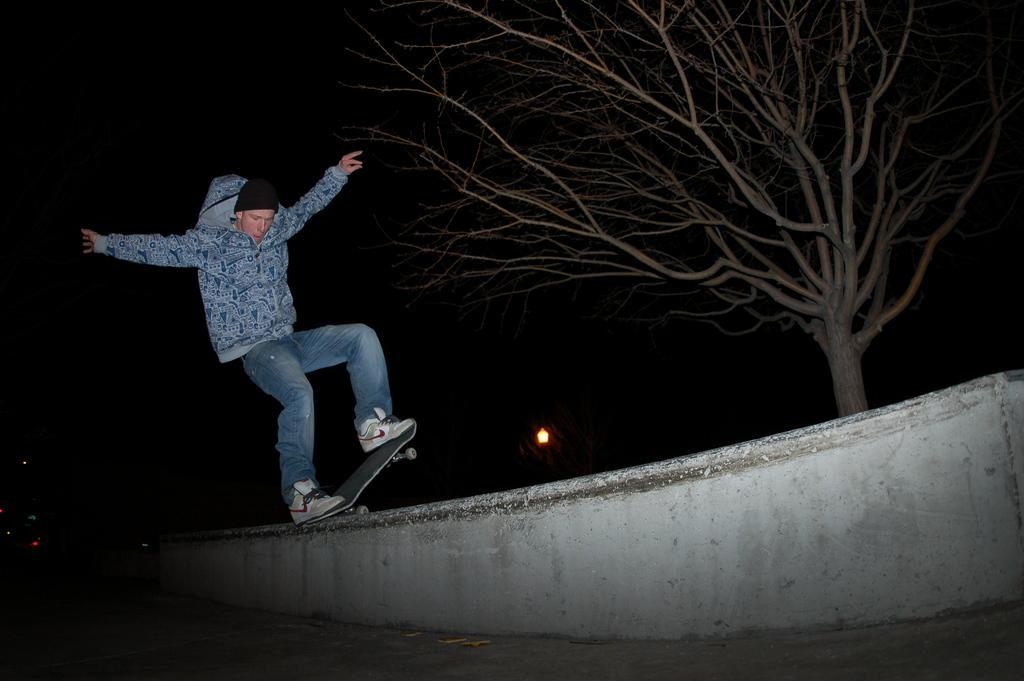What is the main subject of the image? The main subject of the image is a man. What is the man doing in the image? The man is standing on a skateboard and balancing on a wall. What can be seen in the background of the image? There is a dried tree in the image. How would you describe the lighting in the image? The image appears to be set in a dark environment. What type of music can be heard playing in the background of the image? There is no music present in the image; it is a still photograph of a man on a skateboard. Is there a clam visible in the image? No, there is no clam present in the image. 